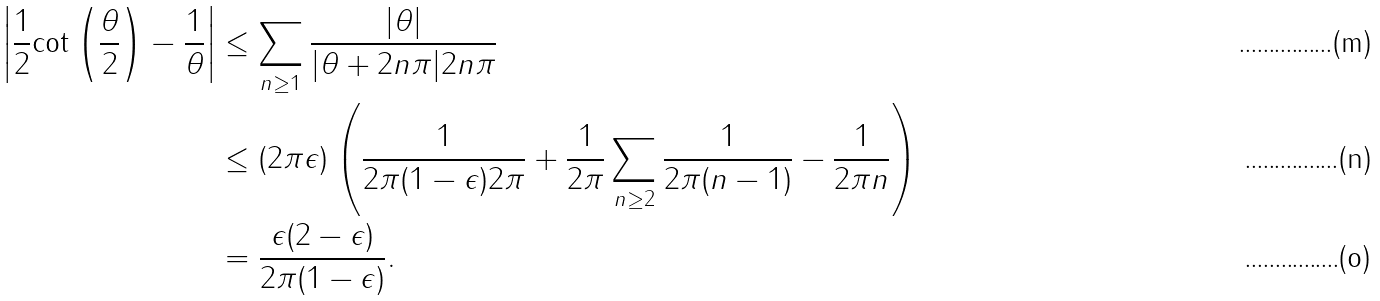Convert formula to latex. <formula><loc_0><loc_0><loc_500><loc_500>\left | \frac { 1 } { 2 } \text {cot} \left ( \frac { \theta } { 2 } \right ) - \frac { 1 } { \theta } \right | & \leq \sum _ { n \geq 1 } \frac { | \theta | } { | \theta + 2 n \pi | 2 n \pi } \\ & \leq ( 2 \pi \epsilon ) \left ( \frac { 1 } { 2 \pi ( 1 - \epsilon ) 2 \pi } + \frac { 1 } { 2 \pi } \sum _ { n \geq 2 } \frac { 1 } { 2 \pi ( n - 1 ) } - \frac { 1 } { 2 \pi n } \right ) \\ & = \frac { \epsilon ( 2 - \epsilon ) } { 2 \pi ( 1 - \epsilon ) } .</formula> 